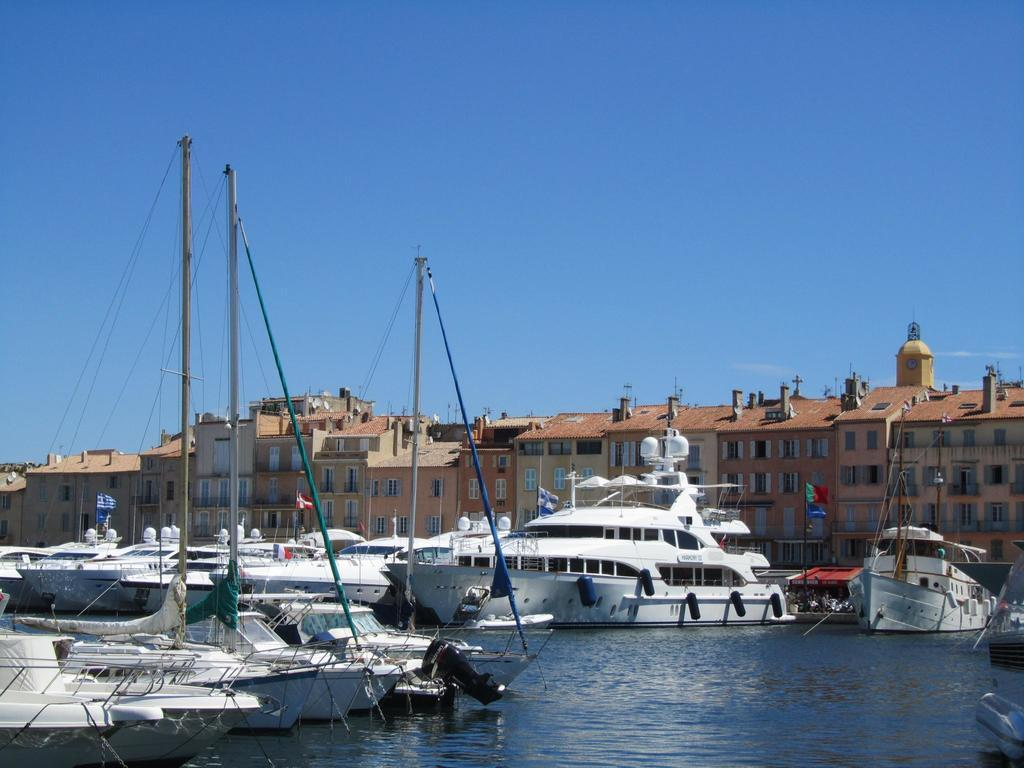What type of vehicles can be seen in the image? There are boats in the image. What color are the boats? The boats are white. What can be seen in the background of the image? There are buildings, glass windows, and flags visible in the background. What natural element is present in the image? There is water visible in the image. What is the color of the sky in the image? The sky is blue and white. Where is the brick wall located in the image? There is no brick wall present in the image. Can you tell me how many deer are visible in the image? There are no deer present in the image. 